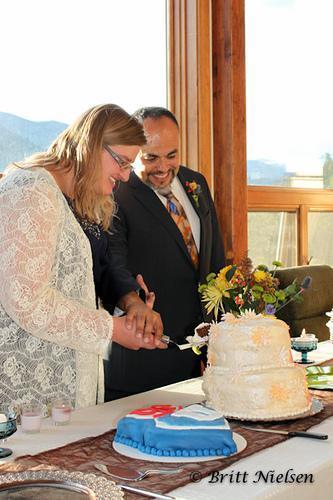How many cakes are shown?
Give a very brief answer. 2. 